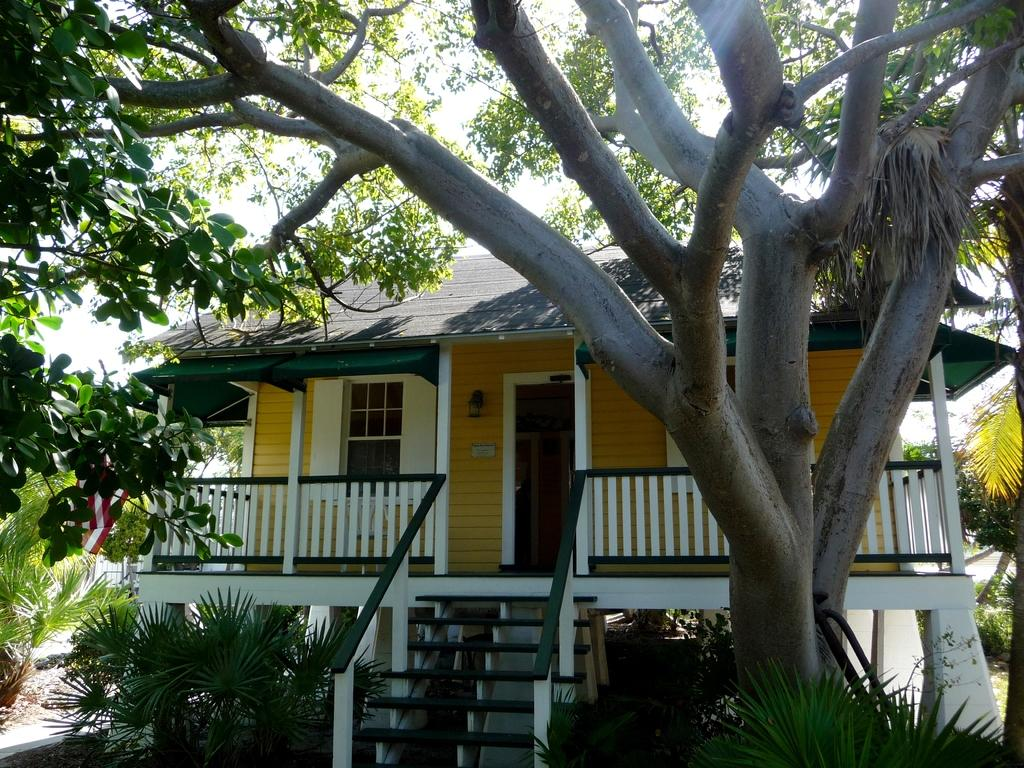What is located in the front of the image? There is a tree in the front of the image. What is the main structure in the center of the image? There is a house in the center of the image. What can be seen in the background of the image? There are trees in the background of the image. What type of vegetation is present in front of the house? There are plants in front of the house. What type of rice is being cooked in the house in the image? There is no indication of cooking or rice in the image; it features a tree, a house, and plants. What idea is being discussed by the trees in the background of the image? There is no indication of a discussion or idea in the image; it features a tree, a house, and plants. 